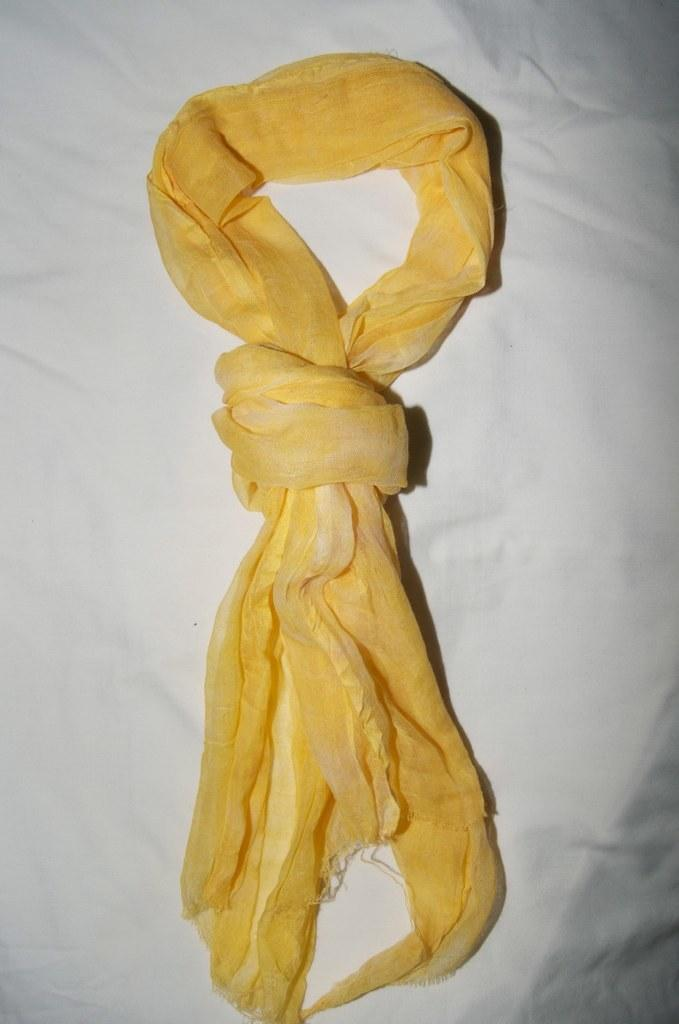What color is the cloth that is visible in the image? The cloth in the image is yellow. What type of furniture is present in the image? There is a bed in the image. How is the bed covered in the image? The bed is covered with a white cloth. What is the weight of the structure in the image? There is no structure mentioned in the image, so it's not possible to determine its weight. 